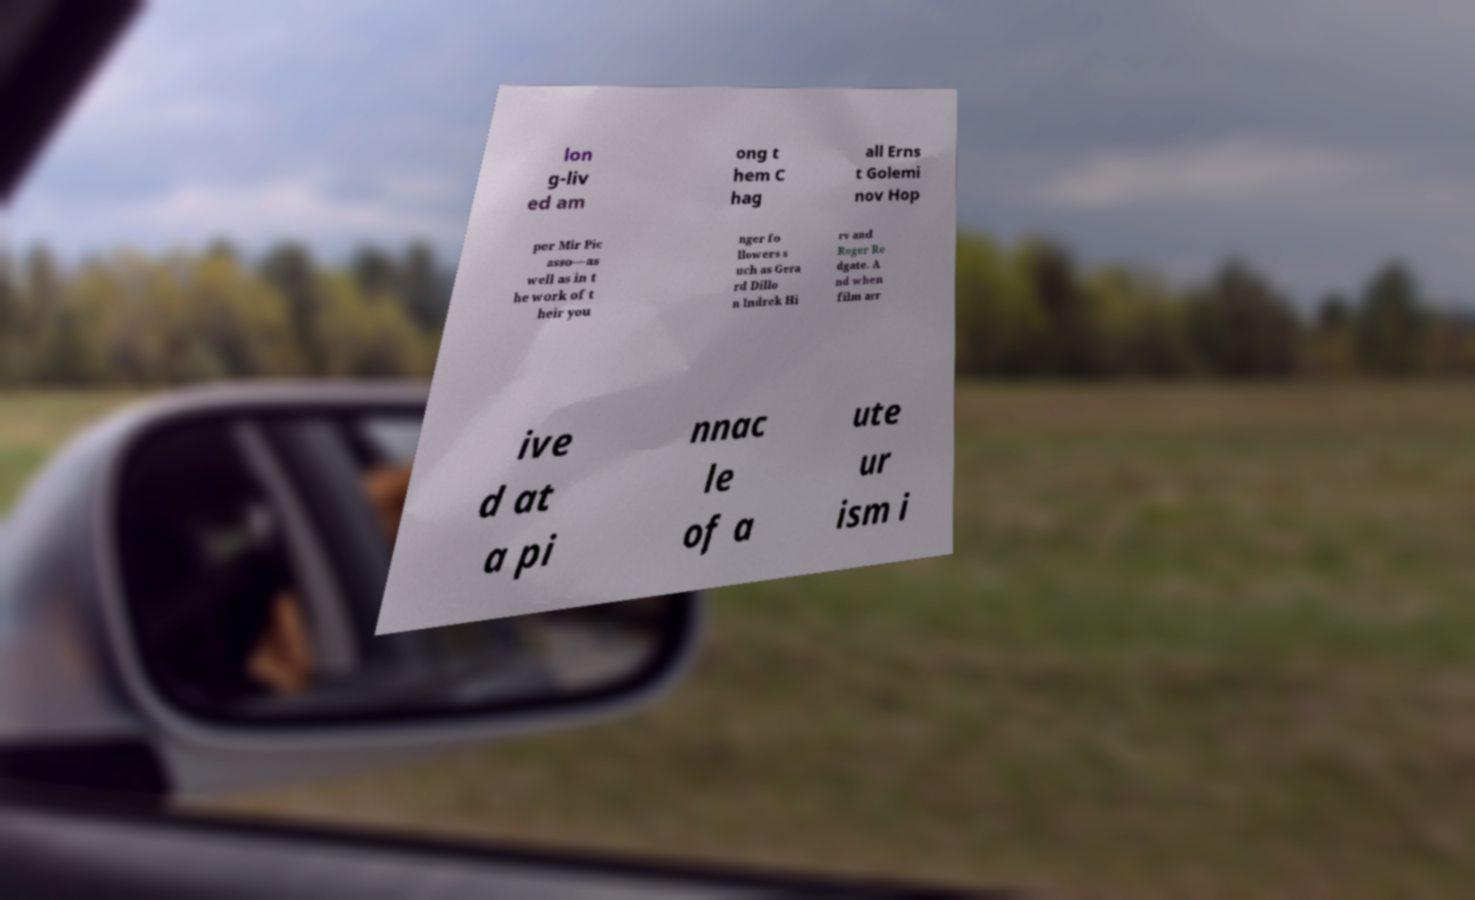Can you accurately transcribe the text from the provided image for me? lon g-liv ed am ong t hem C hag all Erns t Golemi nov Hop per Mir Pic asso—as well as in t he work of t heir you nger fo llowers s uch as Gera rd Dillo n Indrek Hi rv and Roger Re dgate. A nd when film arr ive d at a pi nnac le of a ute ur ism i 